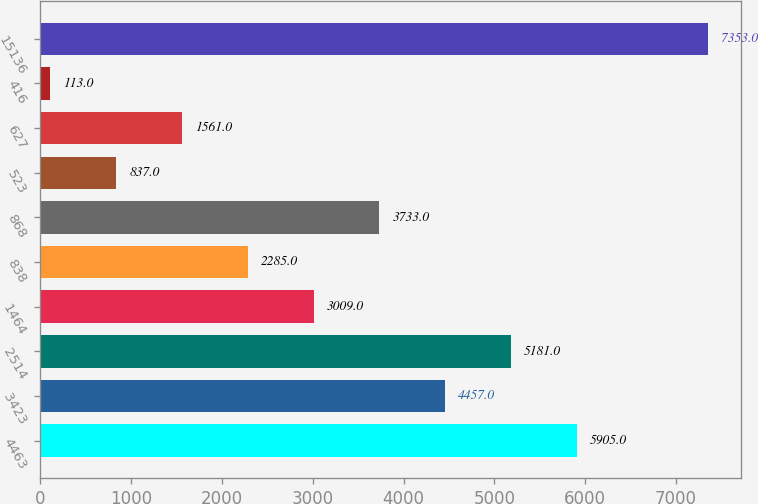Convert chart. <chart><loc_0><loc_0><loc_500><loc_500><bar_chart><fcel>4463<fcel>3423<fcel>2514<fcel>1464<fcel>838<fcel>868<fcel>523<fcel>627<fcel>416<fcel>15136<nl><fcel>5905<fcel>4457<fcel>5181<fcel>3009<fcel>2285<fcel>3733<fcel>837<fcel>1561<fcel>113<fcel>7353<nl></chart> 